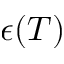<formula> <loc_0><loc_0><loc_500><loc_500>\epsilon ( T )</formula> 